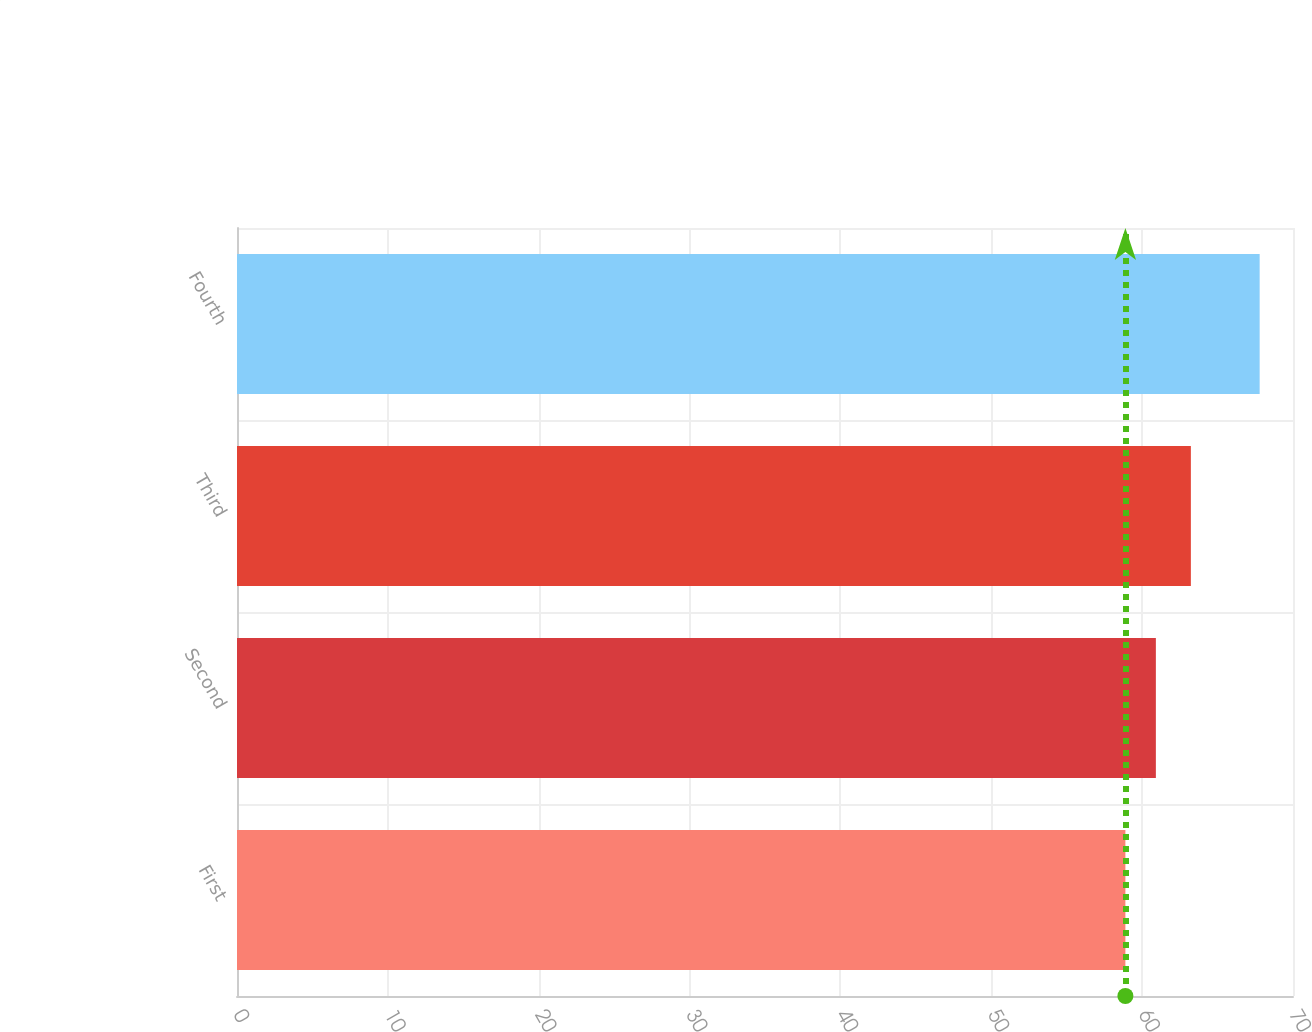Convert chart. <chart><loc_0><loc_0><loc_500><loc_500><bar_chart><fcel>First<fcel>Second<fcel>Third<fcel>Fourth<nl><fcel>58.89<fcel>60.91<fcel>63.23<fcel>67.79<nl></chart> 